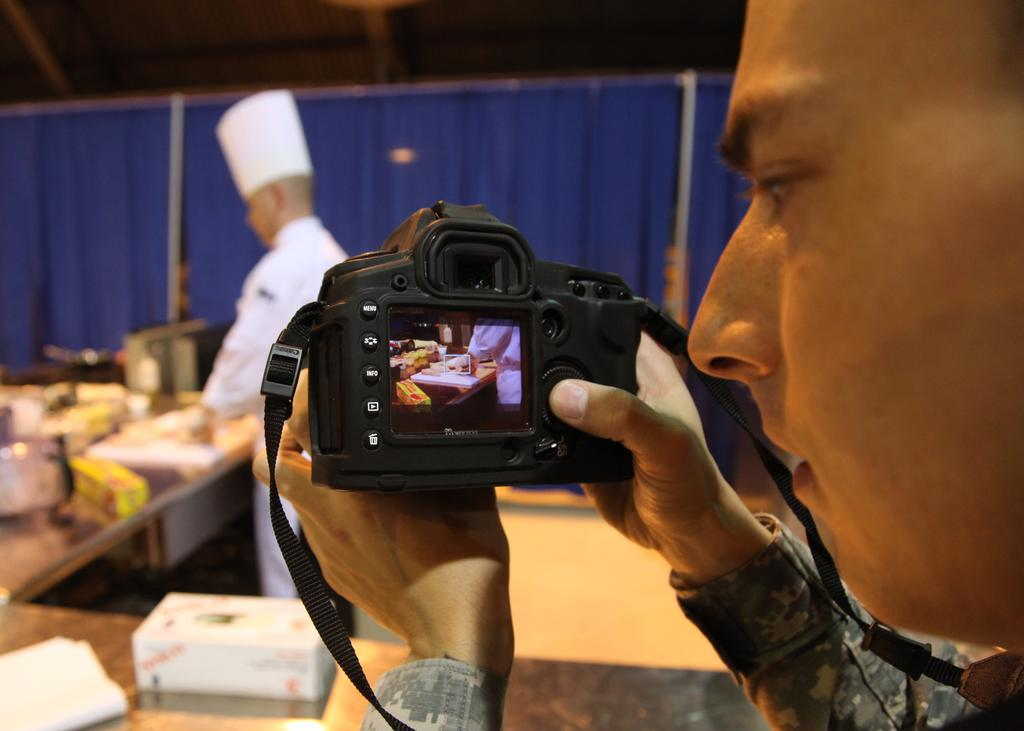What is the man in the image holding? The man is holding a camera in the image. Who is the man focusing on with the camera? The man is focusing on a person behind the lens, who is a chef. What can be seen in front of the chef? There is a table in front of the chef. What is the color of the camera? The camera is black in color. How many frogs are sitting on the curtain in the image? There are no frogs or curtains present in the image. What type of chicken is being prepared on the table by the chef? There is no chicken visible in the image; the chef is not preparing any food. 